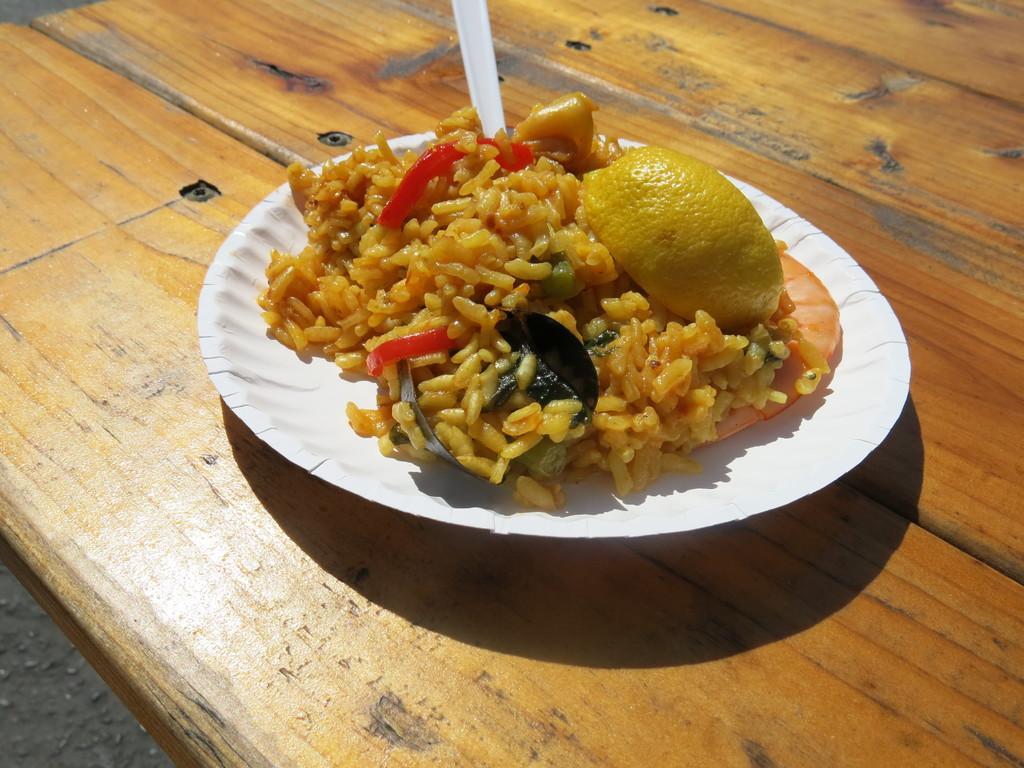Could you give a brief overview of what you see in this image? This image is taken outdoors. At the left bottom of the image there is a floor. At the bottom of the image there is a table with a plate on it. There is a food item and a spoon on the plate. There are a lemon slice, a shrimp and a few vegetable slices. 